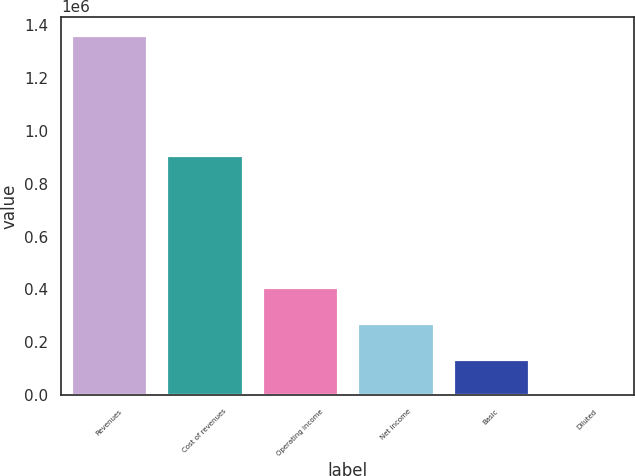<chart> <loc_0><loc_0><loc_500><loc_500><bar_chart><fcel>Revenues<fcel>Cost of revenues<fcel>Operating income<fcel>Net income<fcel>Basic<fcel>Diluted<nl><fcel>1.36466e+06<fcel>910234<fcel>409399<fcel>272933<fcel>136467<fcel>1.32<nl></chart> 